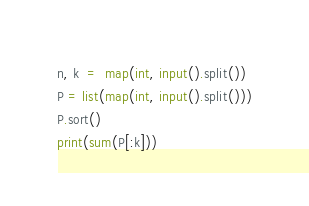<code> <loc_0><loc_0><loc_500><loc_500><_Python_>n, k  =  map(int, input().split())
P = list(map(int, input().split()))
P.sort()
print(sum(P[:k]))</code> 